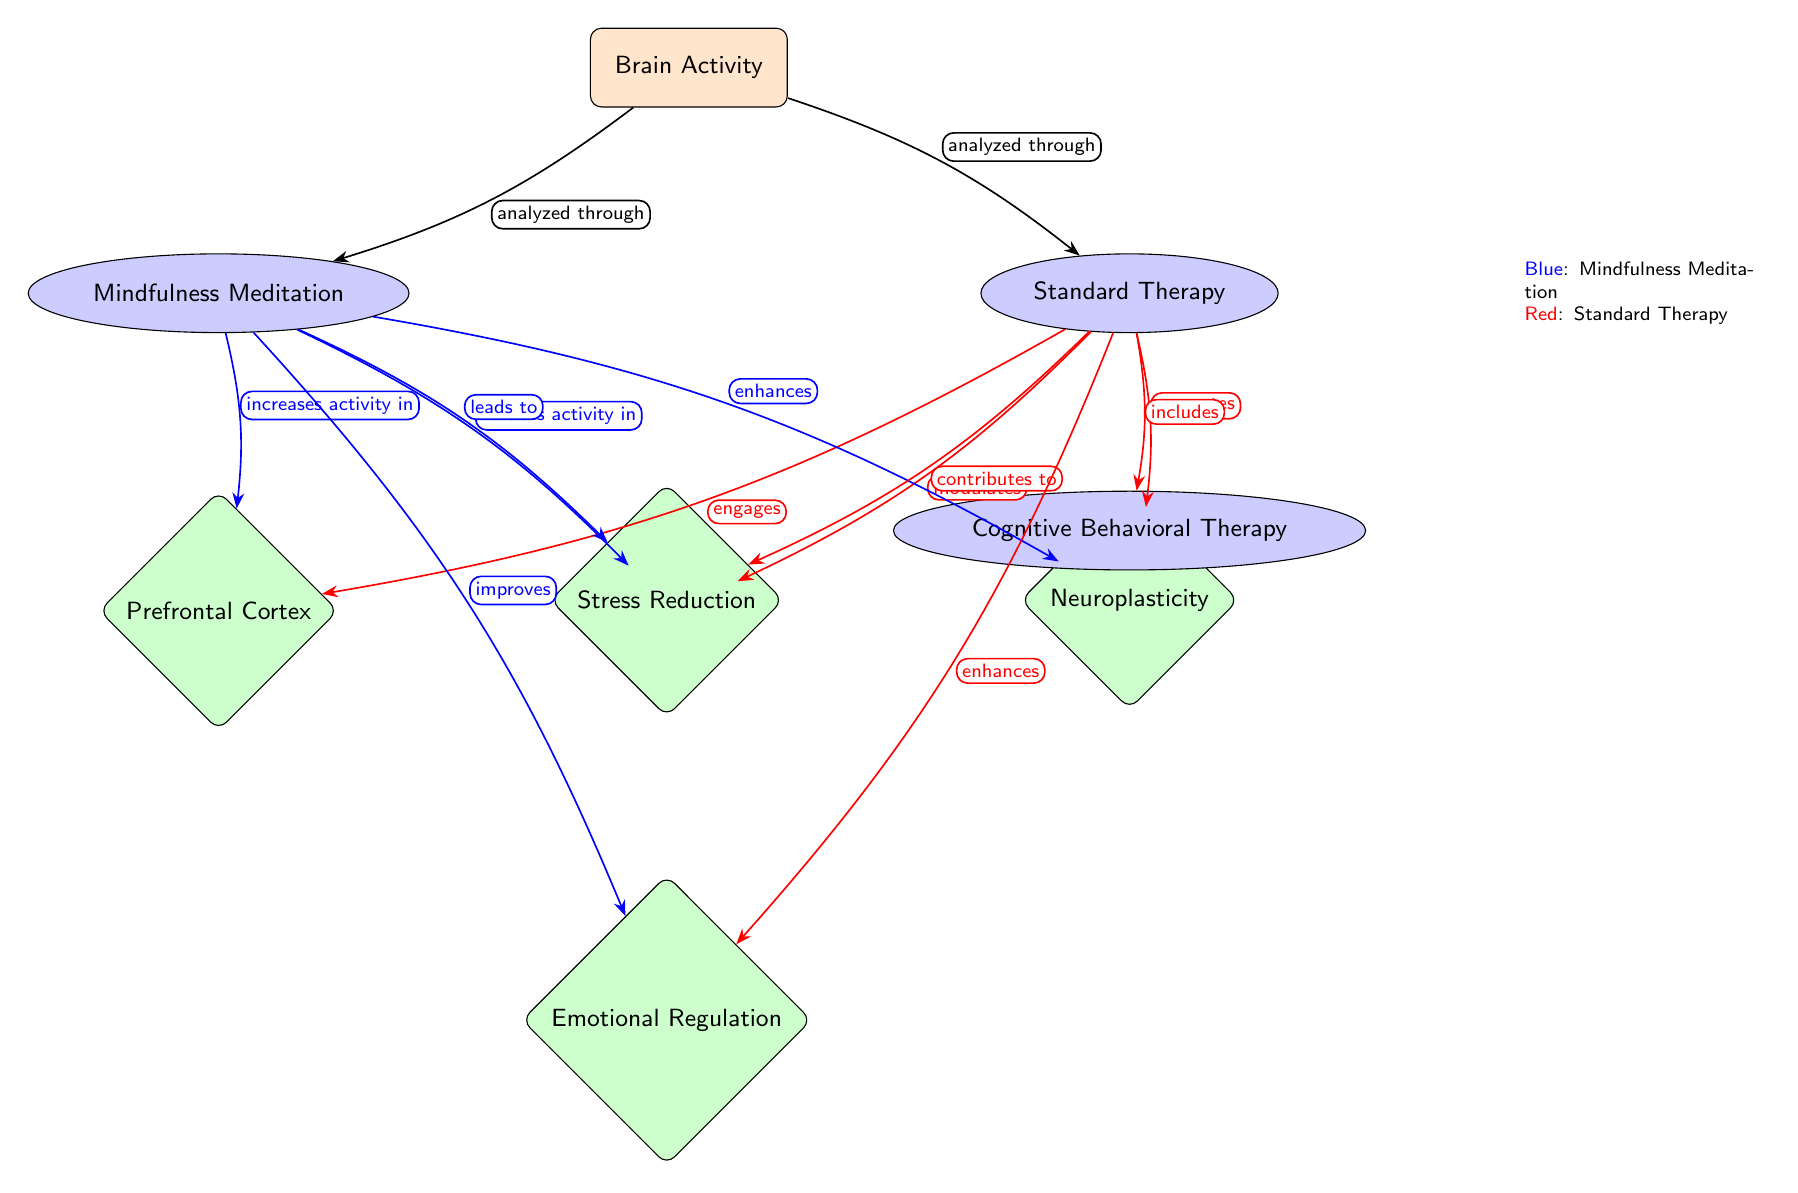What are the two main approaches analyzed in the diagram? The diagram specifically identifies two approaches under "Brain Activity": Mindfulness Meditation and Standard Therapy. These are clearly labeled as the main nodes connected to the central node "Brain Activity."
Answer: Mindfulness Meditation, Standard Therapy Which brain region shows increased activity with Mindfulness Meditation? The diagram indicates that Mindfulness Meditation increases activity in the Prefrontal Cortex, as shown by the blue arrow pointing from Mindfulness Meditation to Prefrontal Cortex labeled "increases activity in."
Answer: Prefrontal Cortex How does Standard Therapy affect the Amygdala? The relationship indicated in the diagram shows that Standard Therapy modulates the Amygdala, as evident from the red arrow pointing from Standard Therapy to Amygdala labeled "modulates."
Answer: Modulates What two benefits does Mindfulness Meditation enhance according to the diagram? The diagram shows that Mindfulness Meditation enhances Neuroplasticity and improves Emotional Regulation, these relationships are represented by the blue arrows labeled "enhances" and "improves," respectively.
Answer: Neuroplasticity, Emotional Regulation What therapeutic approach includes Cognitive Behavioral Therapy? In the diagram, Standard Therapy is linked by a red arrow to Cognitive Behavioral Therapy labeled "includes," indicating that it encompasses this method of treatment.
Answer: Standard Therapy Which practice is associated with stress reduction? The diagram indicates that Mindfulness Meditation leads to Stress Reduction, as shown by the blue arrow pointing from Mindfulness Meditation to Stress Reduction with the label "leads to."
Answer: Mindfulness Meditation 